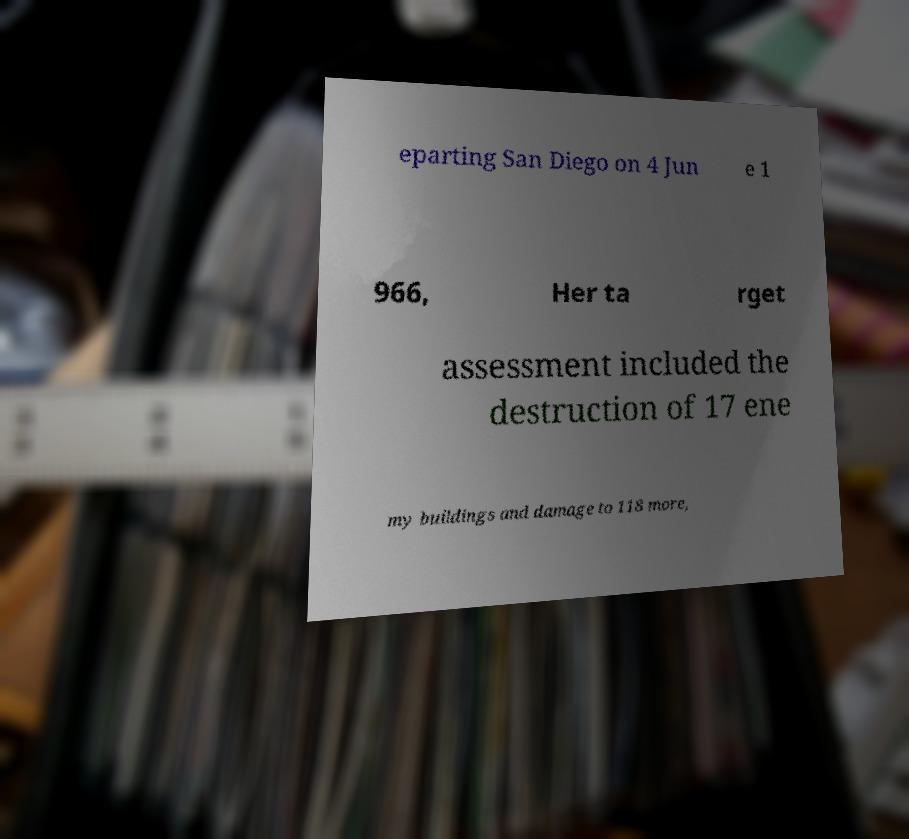I need the written content from this picture converted into text. Can you do that? eparting San Diego on 4 Jun e 1 966, Her ta rget assessment included the destruction of 17 ene my buildings and damage to 118 more, 